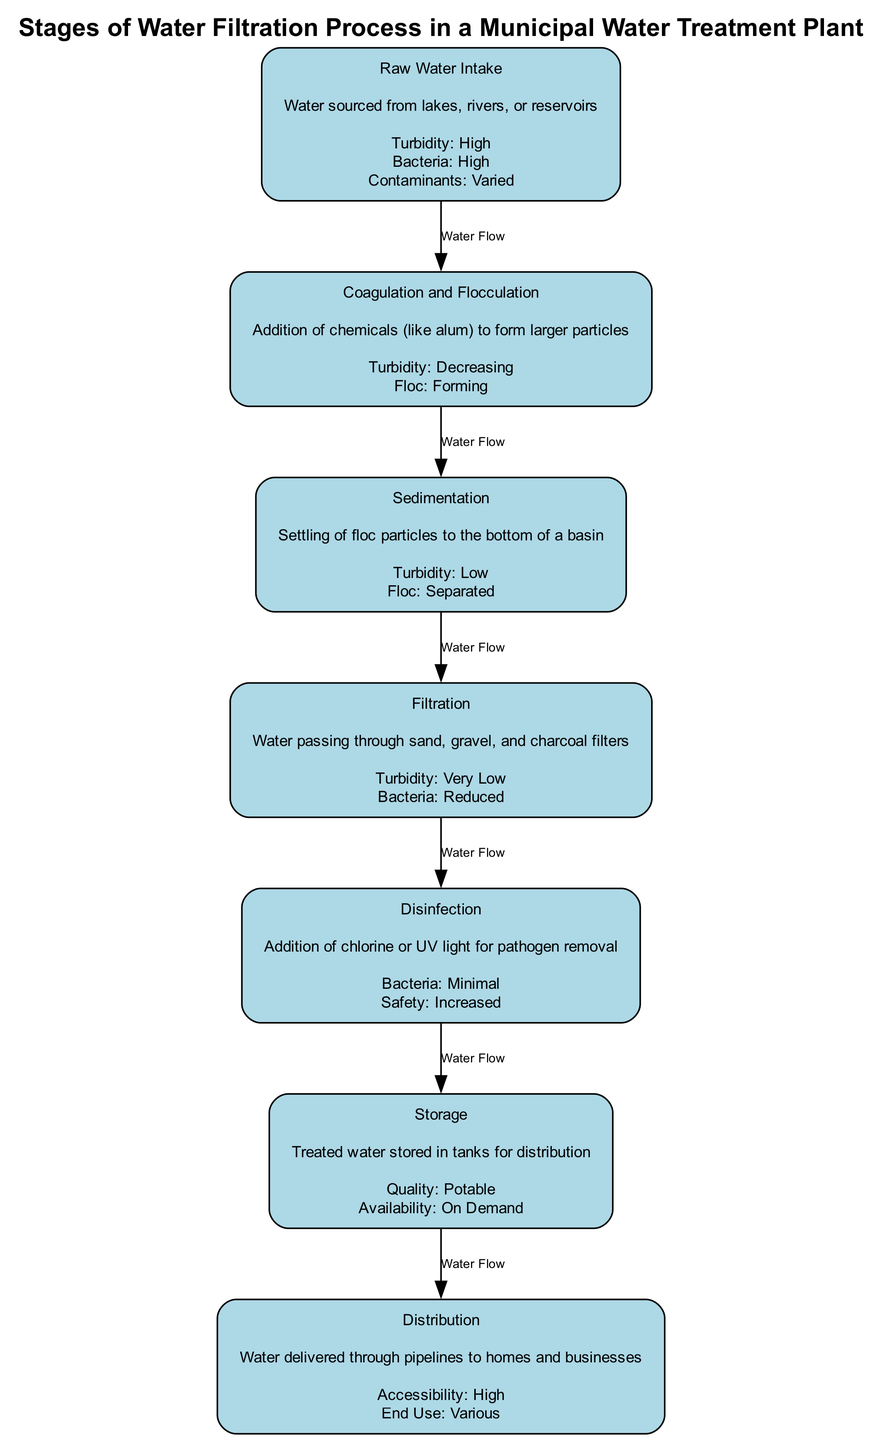What is the first stage of the water filtration process? The diagram clearly labels the first node as "Raw Water Intake," which indicates the initial step in the filtration process.
Answer: Raw Water Intake How many stages are there in the water filtration process? Counting the nodes in the diagram reveals a total of seven stages from Raw Water Intake to Distribution.
Answer: 7 What happens to turbidity during the Coagulation and Flocculation stage? According to the parameters listed in the Coagulation and Flocculation node, turbidity is described as "Decreasing" during this stage.
Answer: Decreasing What is the description of the Filtration stage? The node labeled "Filtration" provides the description "Water passing through sand, gravel, and charcoal filters," which summarizes its purpose effectively.
Answer: Water passing through sand, gravel, and charcoal filters What is the relationship between Sedimentation and Filtration in terms of water flow? The diagram shows an edge labeled "Water Flow" connecting Sedimentation to Filtration, indicating that water flows from one stage to another directly.
Answer: Water Flow How does the Bacteria parameter change from Raw Water Intake to Disinfection? Starting at Raw Water Intake where Bacteria is "High," it reduces in the Filtration stage to "Reduced," and finally reaches "Minimal" in the Disinfection stage, demonstrating a decreasing trend.
Answer: Minimal What is the final stage in the water filtration process? The last node in the diagram is labeled "Distribution," marking it as the concluding step of the filtration process before water is delivered to end-users.
Answer: Distribution What quality is the water stored in tanks at the Storage stage? The Storage stage specifies that the quality of water is "Potable," which indicates it is safe for drinking and consumption.
Answer: Potable What types of end use are indicated in the Distribution stage? The Distribution node mentions "Various" for end use, reflecting the wide applications of the treated water delivered to homes and businesses.
Answer: Various 